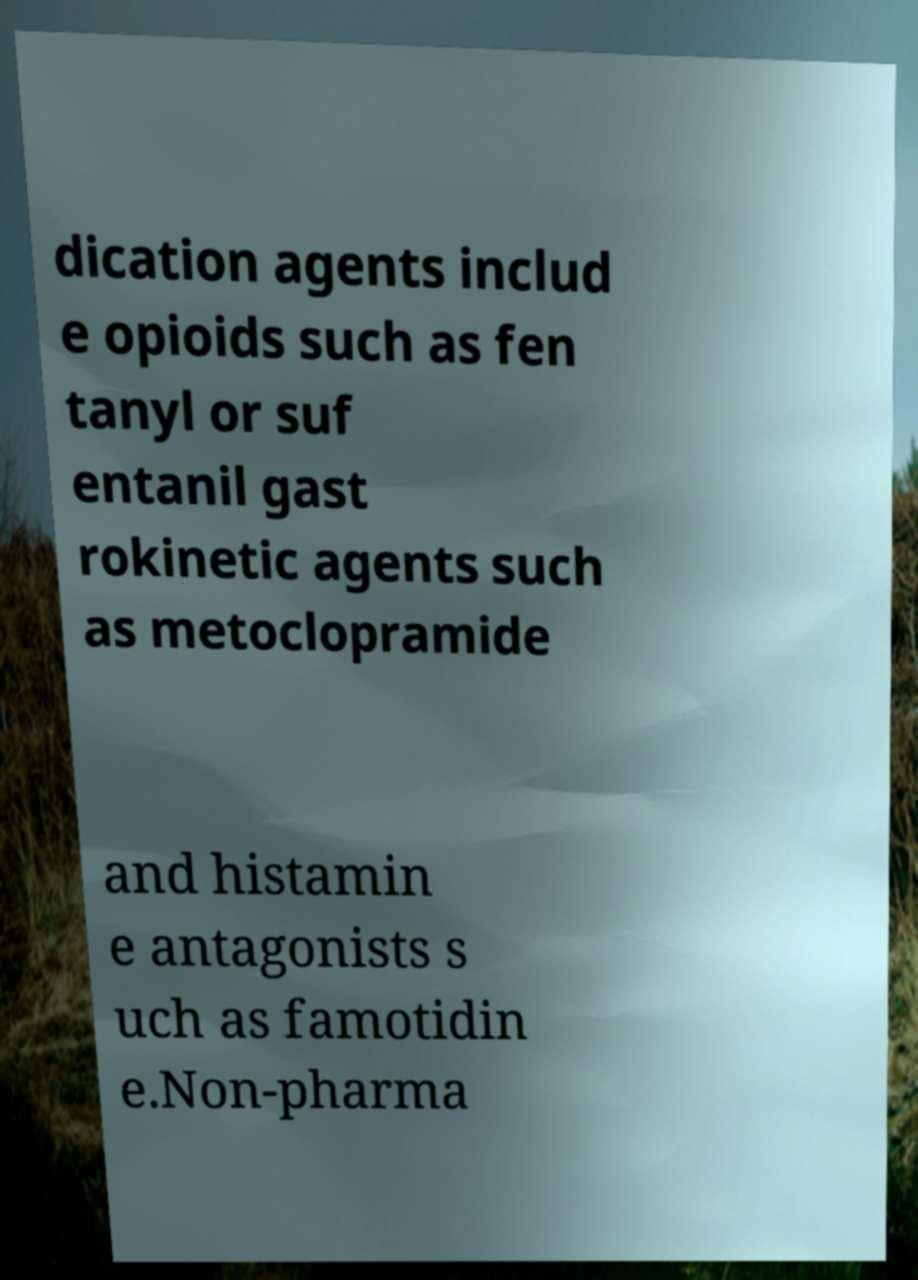Could you extract and type out the text from this image? dication agents includ e opioids such as fen tanyl or suf entanil gast rokinetic agents such as metoclopramide and histamin e antagonists s uch as famotidin e.Non-pharma 